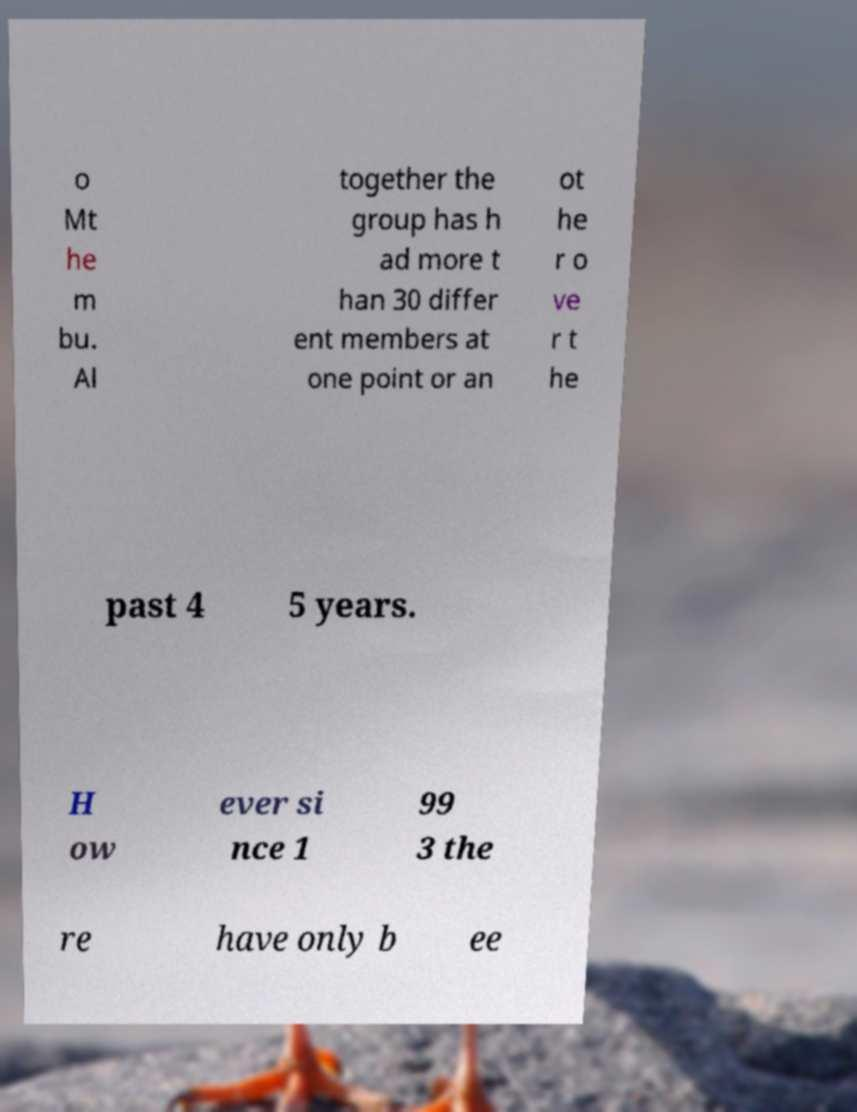I need the written content from this picture converted into text. Can you do that? o Mt he m bu. Al together the group has h ad more t han 30 differ ent members at one point or an ot he r o ve r t he past 4 5 years. H ow ever si nce 1 99 3 the re have only b ee 